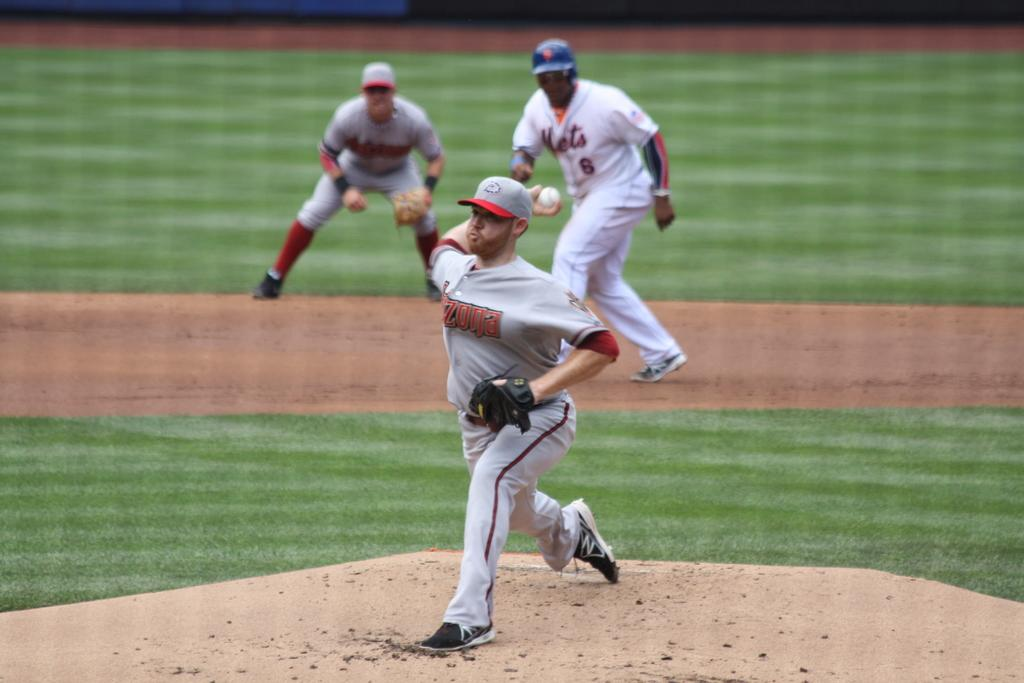Provide a one-sentence caption for the provided image. A pitcher is pitching a baseball behind player number 6. 